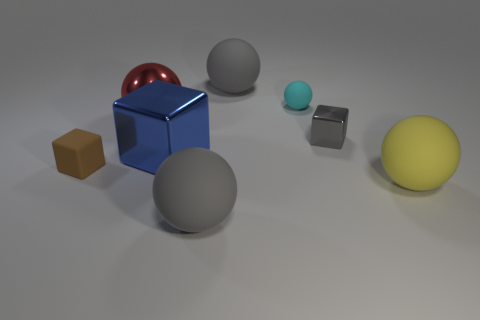Subtract all tiny cyan rubber spheres. How many spheres are left? 4 Subtract all red balls. How many balls are left? 4 Subtract all brown spheres. Subtract all cyan cubes. How many spheres are left? 5 Add 2 purple metallic cylinders. How many objects exist? 10 Subtract all balls. How many objects are left? 3 Add 1 gray spheres. How many gray spheres are left? 3 Add 8 red metal objects. How many red metal objects exist? 9 Subtract 0 green spheres. How many objects are left? 8 Subtract all small cyan spheres. Subtract all red things. How many objects are left? 6 